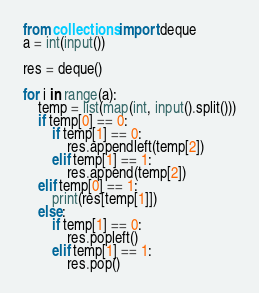Convert code to text. <code><loc_0><loc_0><loc_500><loc_500><_Python_>from collections import deque
a = int(input())

res = deque()

for i in range(a):
    temp = list(map(int, input().split()))
    if temp[0] == 0:
        if temp[1] == 0:
            res.appendleft(temp[2])
        elif temp[1] == 1:
            res.append(temp[2])
    elif temp[0] == 1:
        print(res[temp[1]])
    else:
        if temp[1] == 0:
            res.popleft()
        elif temp[1] == 1:
            res.pop()
</code> 